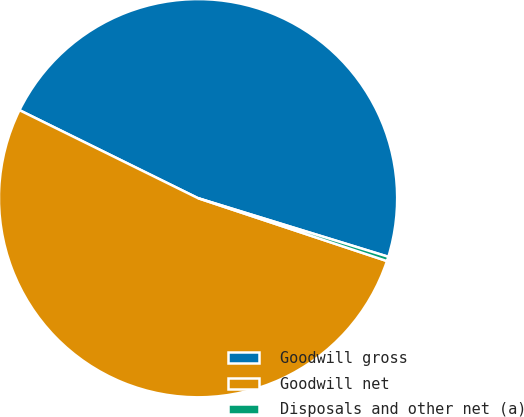Convert chart. <chart><loc_0><loc_0><loc_500><loc_500><pie_chart><fcel>Goodwill gross<fcel>Goodwill net<fcel>Disposals and other net (a)<nl><fcel>47.47%<fcel>52.18%<fcel>0.36%<nl></chart> 